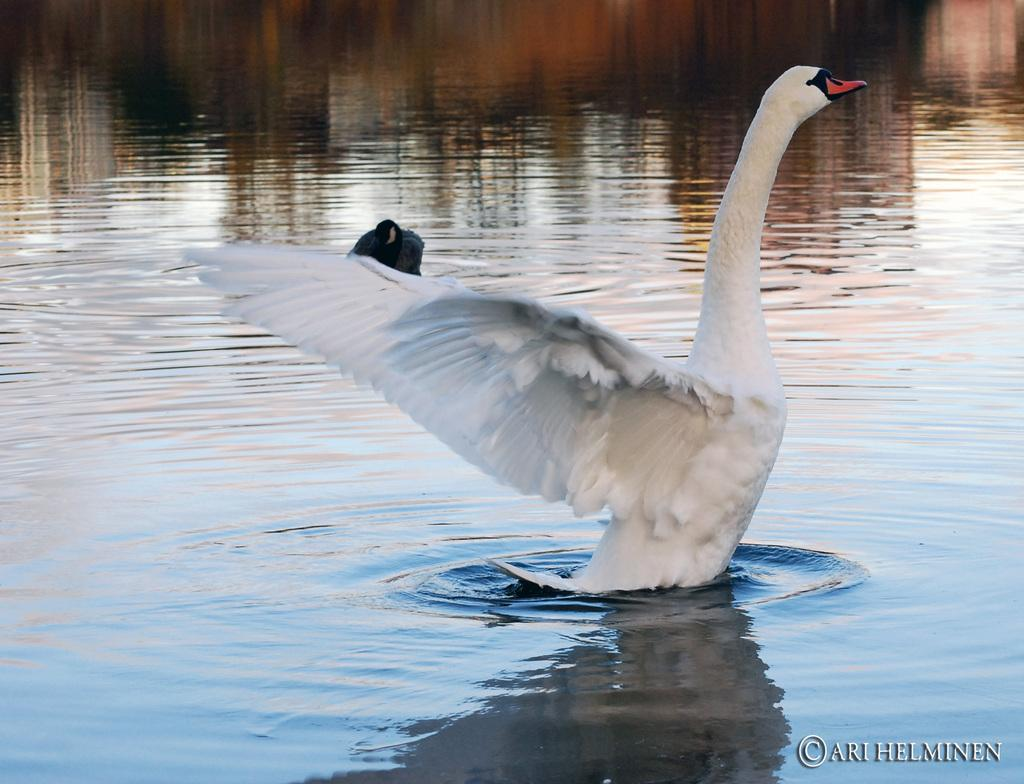What animal is present in the image? There is a swan in the image. Where is the swan located? The swan is in the water. What type of water body might the swan be in? The water might be in a pond. What other bird can be seen in the image? There is a black color bird in the image. What is the color of the background in the image? The background of the image is brown in color. What type of linen is being used to make the swan's skirt in the image? There is no linen or skirt present in the image; it features a swan in the water. How does the black color bird twist its body in the image? There is no indication of the black color bird twisting its body in the image. 